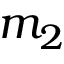Convert formula to latex. <formula><loc_0><loc_0><loc_500><loc_500>m _ { 2 }</formula> 